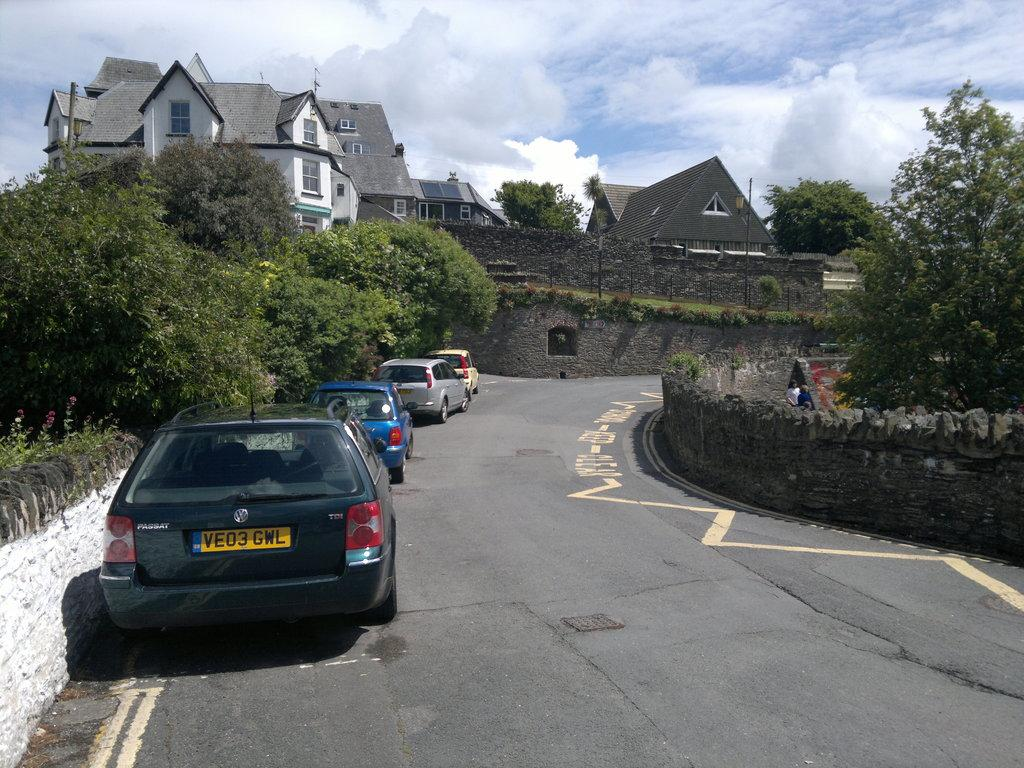What can be seen on the road in the image? There are cars parked on the road in the image. What type of structure is present in the image? There is a stone wall in the image. What type of vegetation is visible in the image? There are trees in the image. What are the people in the image doing? People are walking in the image. What type of buildings can be seen in the image? There are houses in the image. What type of vertical structures are present in the image? There are poles in the image. What is visible in the background of the image? The sky is visible in the background of the image. What can be seen in the sky in the image? Clouds are present in the sky. What type of destruction can be seen in the image? There is no destruction present in the image. How many times do the people in the image sneeze? There is no indication of anyone sneezing in the image. 